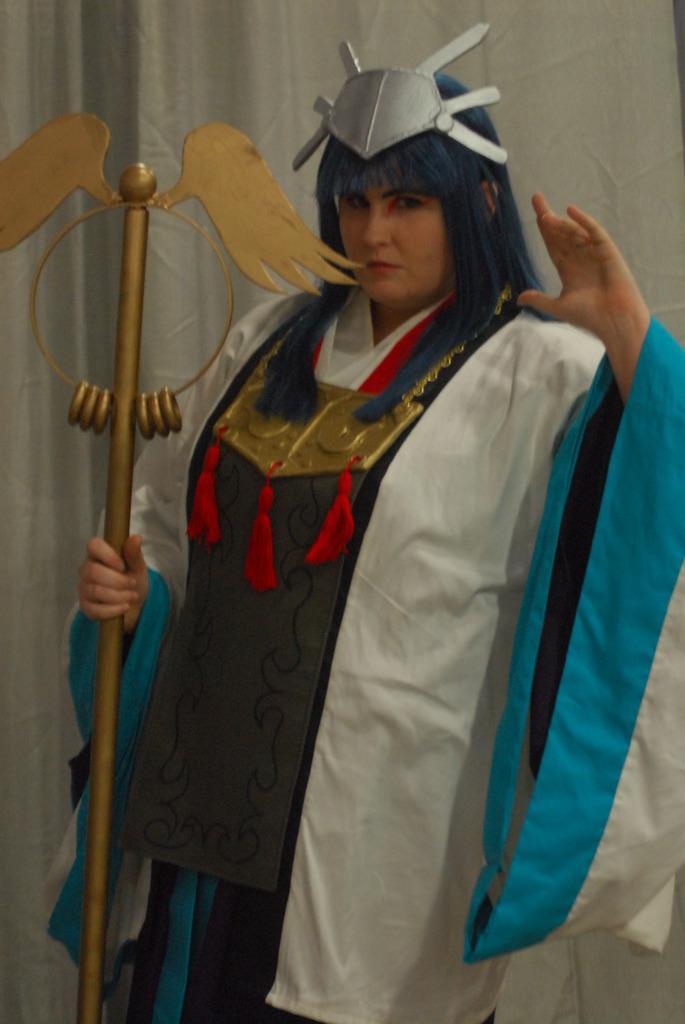Can you describe this image briefly? There is a woman standing in the center holding a stick in her hand in this image and there is a white colour curtain in the background. 